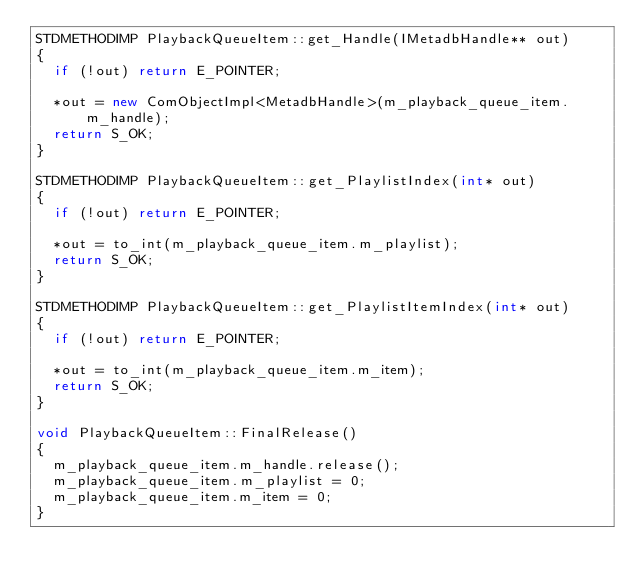<code> <loc_0><loc_0><loc_500><loc_500><_C++_>STDMETHODIMP PlaybackQueueItem::get_Handle(IMetadbHandle** out)
{
	if (!out) return E_POINTER;

	*out = new ComObjectImpl<MetadbHandle>(m_playback_queue_item.m_handle);
	return S_OK;
}

STDMETHODIMP PlaybackQueueItem::get_PlaylistIndex(int* out)
{
	if (!out) return E_POINTER;

	*out = to_int(m_playback_queue_item.m_playlist);
	return S_OK;
}

STDMETHODIMP PlaybackQueueItem::get_PlaylistItemIndex(int* out)
{
	if (!out) return E_POINTER;

	*out = to_int(m_playback_queue_item.m_item);
	return S_OK;
}

void PlaybackQueueItem::FinalRelease()
{
	m_playback_queue_item.m_handle.release();
	m_playback_queue_item.m_playlist = 0;
	m_playback_queue_item.m_item = 0;
}
</code> 